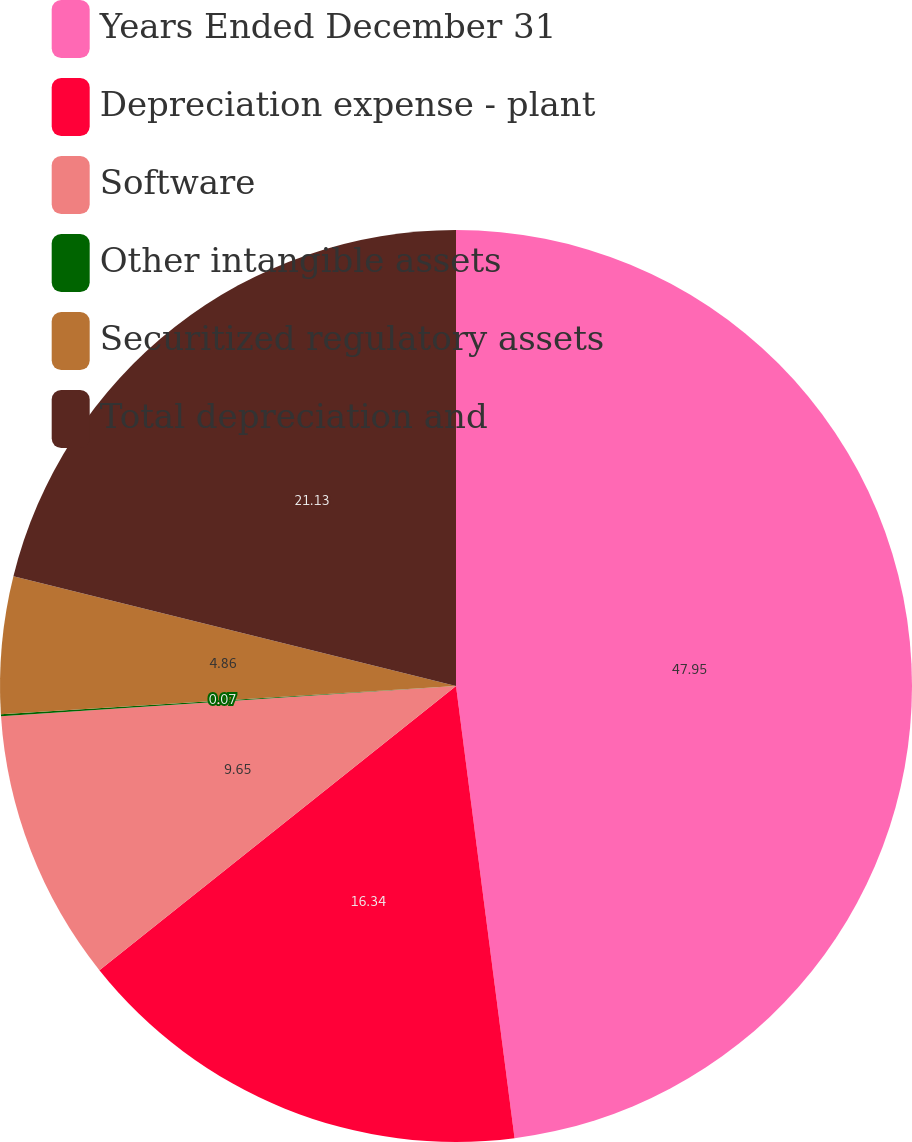Convert chart. <chart><loc_0><loc_0><loc_500><loc_500><pie_chart><fcel>Years Ended December 31<fcel>Depreciation expense - plant<fcel>Software<fcel>Other intangible assets<fcel>Securitized regulatory assets<fcel>Total depreciation and<nl><fcel>47.95%<fcel>16.34%<fcel>9.65%<fcel>0.07%<fcel>4.86%<fcel>21.13%<nl></chart> 